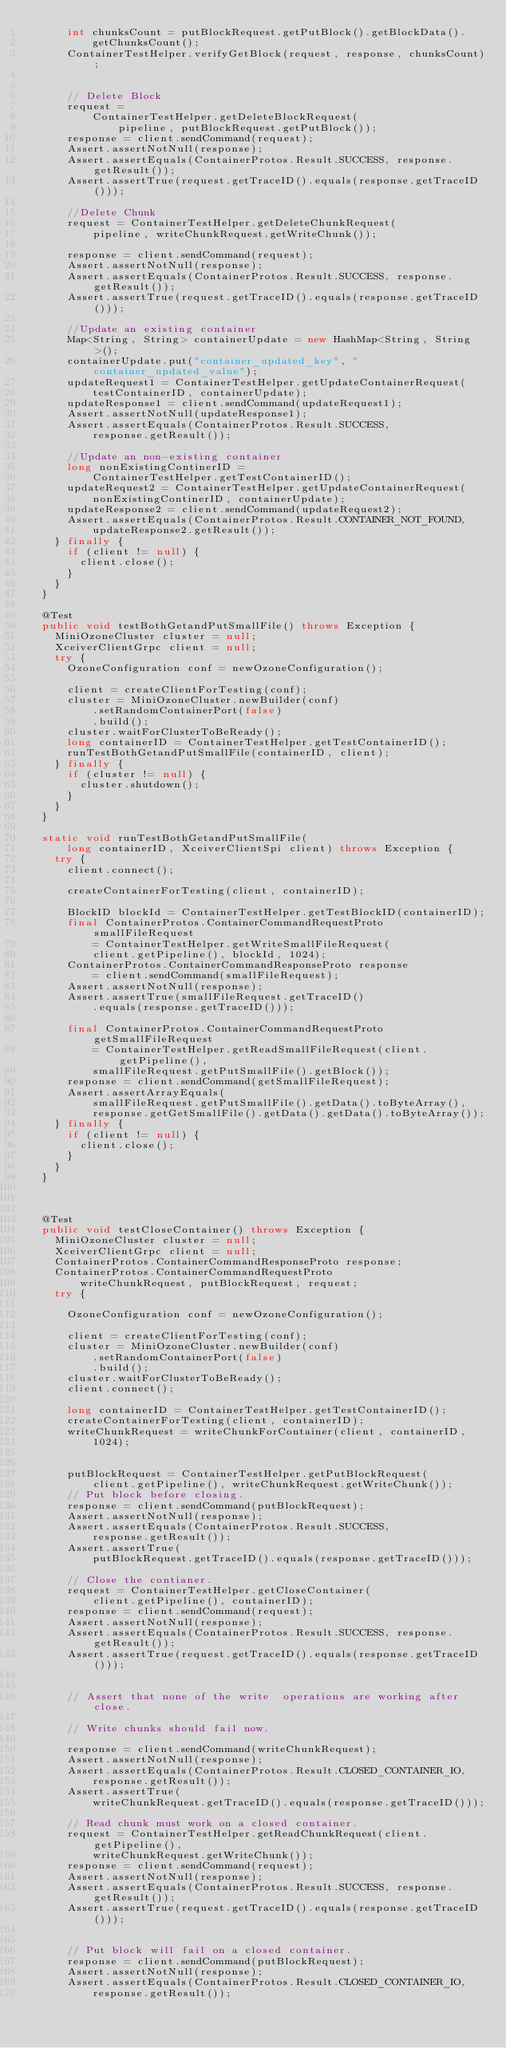Convert code to text. <code><loc_0><loc_0><loc_500><loc_500><_Java_>      int chunksCount = putBlockRequest.getPutBlock().getBlockData().
          getChunksCount();
      ContainerTestHelper.verifyGetBlock(request, response, chunksCount);


      // Delete Block
      request =
          ContainerTestHelper.getDeleteBlockRequest(
              pipeline, putBlockRequest.getPutBlock());
      response = client.sendCommand(request);
      Assert.assertNotNull(response);
      Assert.assertEquals(ContainerProtos.Result.SUCCESS, response.getResult());
      Assert.assertTrue(request.getTraceID().equals(response.getTraceID()));

      //Delete Chunk
      request = ContainerTestHelper.getDeleteChunkRequest(
          pipeline, writeChunkRequest.getWriteChunk());

      response = client.sendCommand(request);
      Assert.assertNotNull(response);
      Assert.assertEquals(ContainerProtos.Result.SUCCESS, response.getResult());
      Assert.assertTrue(request.getTraceID().equals(response.getTraceID()));

      //Update an existing container
      Map<String, String> containerUpdate = new HashMap<String, String>();
      containerUpdate.put("container_updated_key", "container_updated_value");
      updateRequest1 = ContainerTestHelper.getUpdateContainerRequest(
          testContainerID, containerUpdate);
      updateResponse1 = client.sendCommand(updateRequest1);
      Assert.assertNotNull(updateResponse1);
      Assert.assertEquals(ContainerProtos.Result.SUCCESS,
          response.getResult());

      //Update an non-existing container
      long nonExistingContinerID =
          ContainerTestHelper.getTestContainerID();
      updateRequest2 = ContainerTestHelper.getUpdateContainerRequest(
          nonExistingContinerID, containerUpdate);
      updateResponse2 = client.sendCommand(updateRequest2);
      Assert.assertEquals(ContainerProtos.Result.CONTAINER_NOT_FOUND,
          updateResponse2.getResult());
    } finally {
      if (client != null) {
        client.close();
      }
    }
  }

  @Test
  public void testBothGetandPutSmallFile() throws Exception {
    MiniOzoneCluster cluster = null;
    XceiverClientGrpc client = null;
    try {
      OzoneConfiguration conf = newOzoneConfiguration();

      client = createClientForTesting(conf);
      cluster = MiniOzoneCluster.newBuilder(conf)
          .setRandomContainerPort(false)
          .build();
      cluster.waitForClusterToBeReady();
      long containerID = ContainerTestHelper.getTestContainerID();
      runTestBothGetandPutSmallFile(containerID, client);
    } finally {
      if (cluster != null) {
        cluster.shutdown();
      }
    }
  }

  static void runTestBothGetandPutSmallFile(
      long containerID, XceiverClientSpi client) throws Exception {
    try {
      client.connect();

      createContainerForTesting(client, containerID);

      BlockID blockId = ContainerTestHelper.getTestBlockID(containerID);
      final ContainerProtos.ContainerCommandRequestProto smallFileRequest
          = ContainerTestHelper.getWriteSmallFileRequest(
          client.getPipeline(), blockId, 1024);
      ContainerProtos.ContainerCommandResponseProto response
          = client.sendCommand(smallFileRequest);
      Assert.assertNotNull(response);
      Assert.assertTrue(smallFileRequest.getTraceID()
          .equals(response.getTraceID()));

      final ContainerProtos.ContainerCommandRequestProto getSmallFileRequest
          = ContainerTestHelper.getReadSmallFileRequest(client.getPipeline(),
          smallFileRequest.getPutSmallFile().getBlock());
      response = client.sendCommand(getSmallFileRequest);
      Assert.assertArrayEquals(
          smallFileRequest.getPutSmallFile().getData().toByteArray(),
          response.getGetSmallFile().getData().getData().toByteArray());
    } finally {
      if (client != null) {
        client.close();
      }
    }
  }



  @Test
  public void testCloseContainer() throws Exception {
    MiniOzoneCluster cluster = null;
    XceiverClientGrpc client = null;
    ContainerProtos.ContainerCommandResponseProto response;
    ContainerProtos.ContainerCommandRequestProto
        writeChunkRequest, putBlockRequest, request;
    try {

      OzoneConfiguration conf = newOzoneConfiguration();

      client = createClientForTesting(conf);
      cluster = MiniOzoneCluster.newBuilder(conf)
          .setRandomContainerPort(false)
          .build();
      cluster.waitForClusterToBeReady();
      client.connect();

      long containerID = ContainerTestHelper.getTestContainerID();
      createContainerForTesting(client, containerID);
      writeChunkRequest = writeChunkForContainer(client, containerID,
          1024);


      putBlockRequest = ContainerTestHelper.getPutBlockRequest(
          client.getPipeline(), writeChunkRequest.getWriteChunk());
      // Put block before closing.
      response = client.sendCommand(putBlockRequest);
      Assert.assertNotNull(response);
      Assert.assertEquals(ContainerProtos.Result.SUCCESS,
          response.getResult());
      Assert.assertTrue(
          putBlockRequest.getTraceID().equals(response.getTraceID()));

      // Close the contianer.
      request = ContainerTestHelper.getCloseContainer(
          client.getPipeline(), containerID);
      response = client.sendCommand(request);
      Assert.assertNotNull(response);
      Assert.assertEquals(ContainerProtos.Result.SUCCESS, response.getResult());
      Assert.assertTrue(request.getTraceID().equals(response.getTraceID()));


      // Assert that none of the write  operations are working after close.

      // Write chunks should fail now.

      response = client.sendCommand(writeChunkRequest);
      Assert.assertNotNull(response);
      Assert.assertEquals(ContainerProtos.Result.CLOSED_CONTAINER_IO,
          response.getResult());
      Assert.assertTrue(
          writeChunkRequest.getTraceID().equals(response.getTraceID()));

      // Read chunk must work on a closed container.
      request = ContainerTestHelper.getReadChunkRequest(client.getPipeline(),
          writeChunkRequest.getWriteChunk());
      response = client.sendCommand(request);
      Assert.assertNotNull(response);
      Assert.assertEquals(ContainerProtos.Result.SUCCESS, response.getResult());
      Assert.assertTrue(request.getTraceID().equals(response.getTraceID()));


      // Put block will fail on a closed container.
      response = client.sendCommand(putBlockRequest);
      Assert.assertNotNull(response);
      Assert.assertEquals(ContainerProtos.Result.CLOSED_CONTAINER_IO,
          response.getResult());</code> 